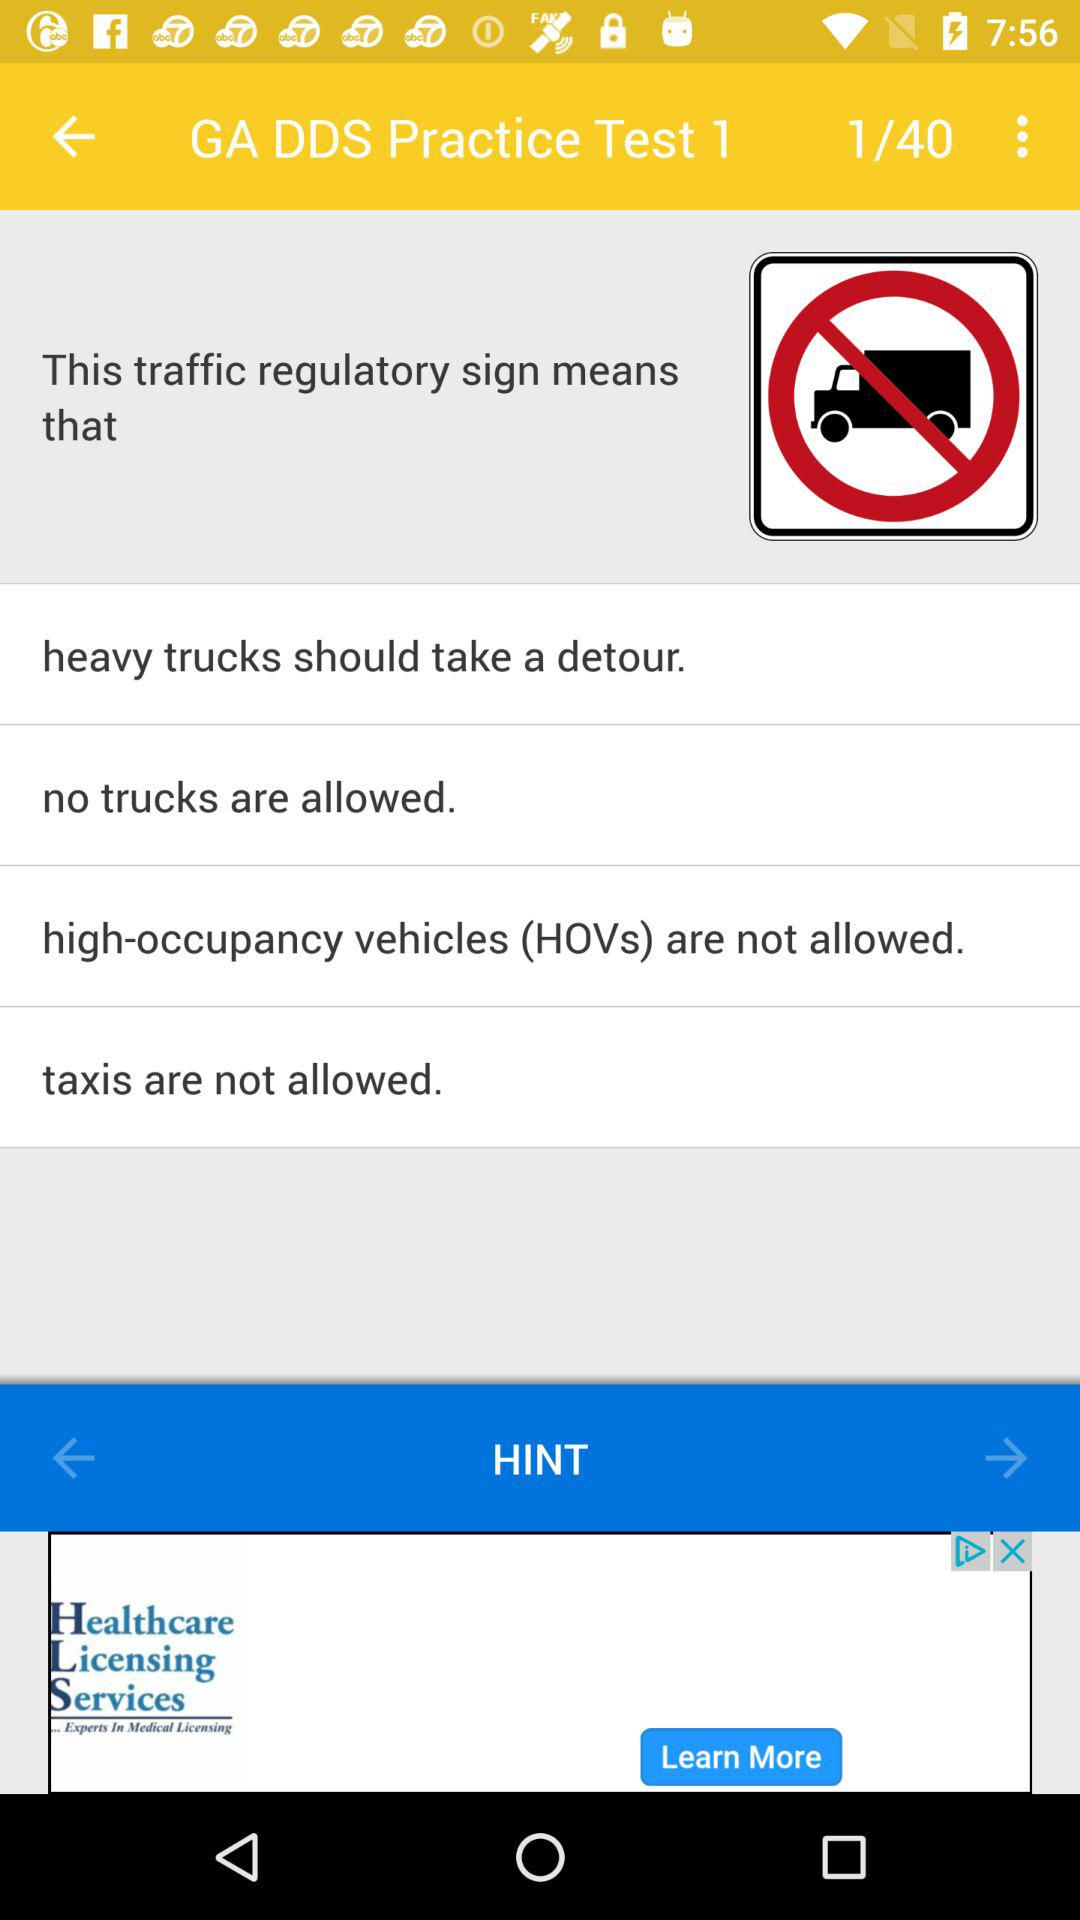How many options are there for what the traffic regulatory sign means?
Answer the question using a single word or phrase. 4 